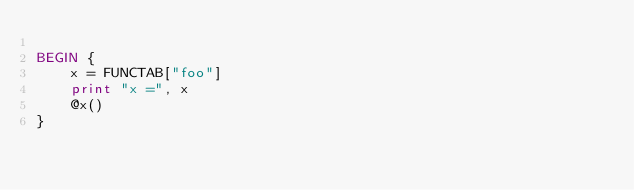<code> <loc_0><loc_0><loc_500><loc_500><_Awk_>
BEGIN {
	x = FUNCTAB["foo"]
	print "x =", x
	@x()
}
</code> 